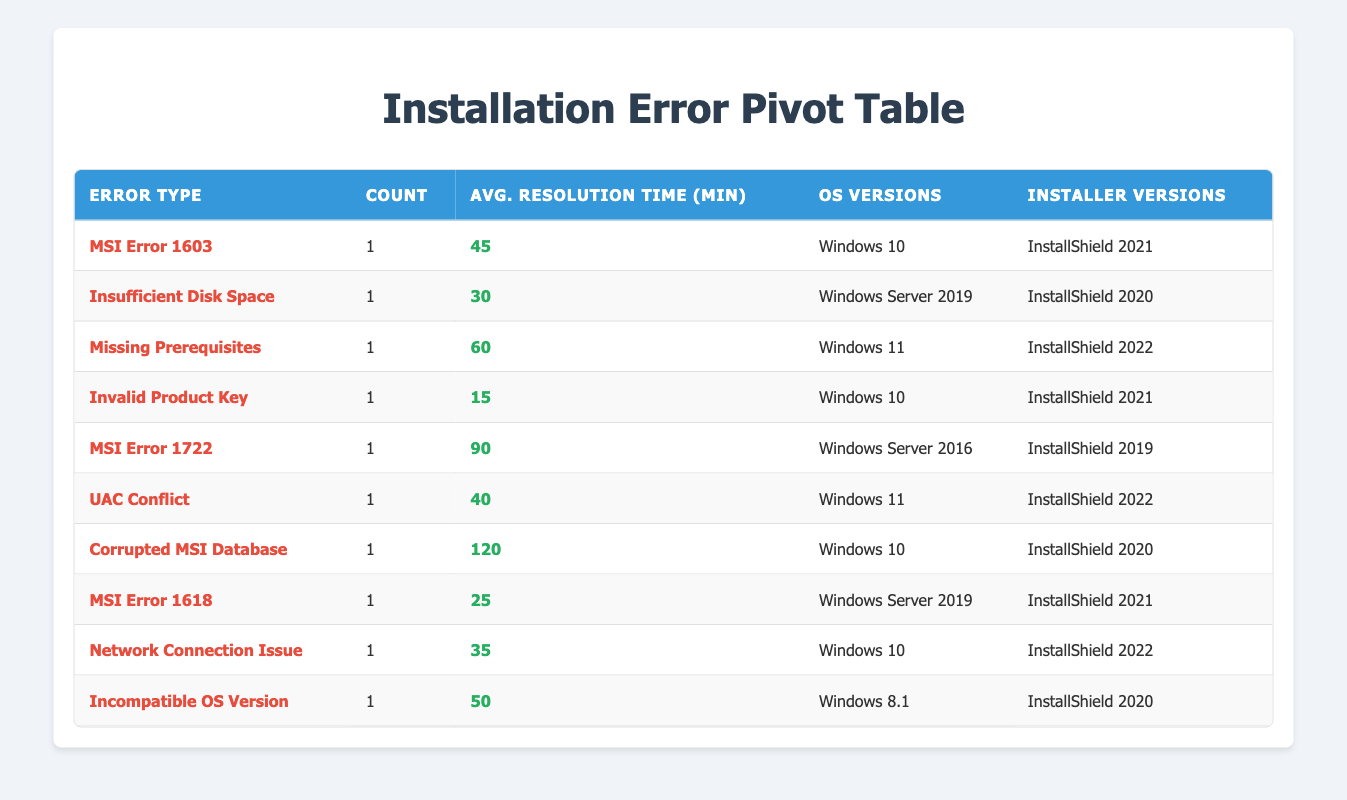What is the most common installation error type? There is one instance of each error type, so no type occurs more than once.
Answer: No common error type What is the average resolution time for tickets categorized as MSI Error 1603? There is one ticket for MSI Error 1603 with a resolution time of 45 minutes. The average is simply the resolution time of that one ticket.
Answer: 45 Which error type has the longest resolution time? Corrupted MSI Database has the longest resolution time of 120 minutes. By checking the resolution times listed, we identify that 120 is the maximum value.
Answer: Corrupted MSI Database How many tickets were categorized as issues related to Windows 10? The tickets for Windows 10 are T1001, T1004, T1007, and T1009. Counting those tickets gives a total of 4.
Answer: 4 Are there any tickets categorized under Insufficient Disk Space? There is 1 ticket for Insufficient Disk Space, specifically ticket T1002. Referring the table, this confirms the presence of the error type.
Answer: Yes What is the average resolution time of tickets for InstallShield 2022? The tickets for InstallShield 2022 are for Missing Prerequisites (60 minutes), UAC Conflict (40 minutes), and Network Connection Issue (35 minutes). Summing these gives 135, and dividing by 3 gives an average of 45.
Answer: 45 Which Installer Version is associated with the highest resolution time? The highest resolution time of 120 minutes is associated with InstallShield 2020, as identified from the respective error type, Corrupted MSI Database.
Answer: InstallShield 2020 Is there more than one ticket for MSI Error 1722? There is only one ticket for MSI Error 1722, which is ticket T1005. By examining the number of occurrences in the error type column, we see there’s just one.
Answer: No What is the total count of different error types represented in the table? The total number of error types in the table is 10, as each row represents a unique error type. Counting them results in 10 distinct entries.
Answer: 10 